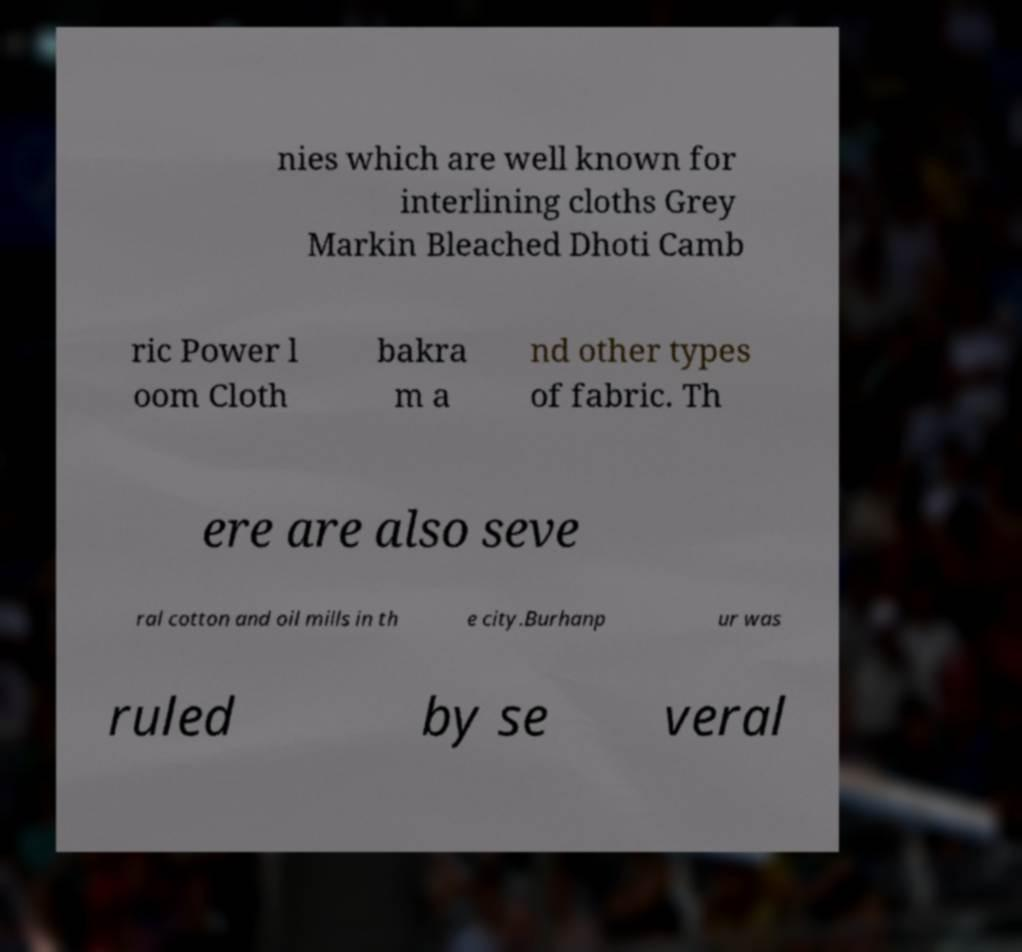Could you assist in decoding the text presented in this image and type it out clearly? nies which are well known for interlining cloths Grey Markin Bleached Dhoti Camb ric Power l oom Cloth bakra m a nd other types of fabric. Th ere are also seve ral cotton and oil mills in th e city.Burhanp ur was ruled by se veral 